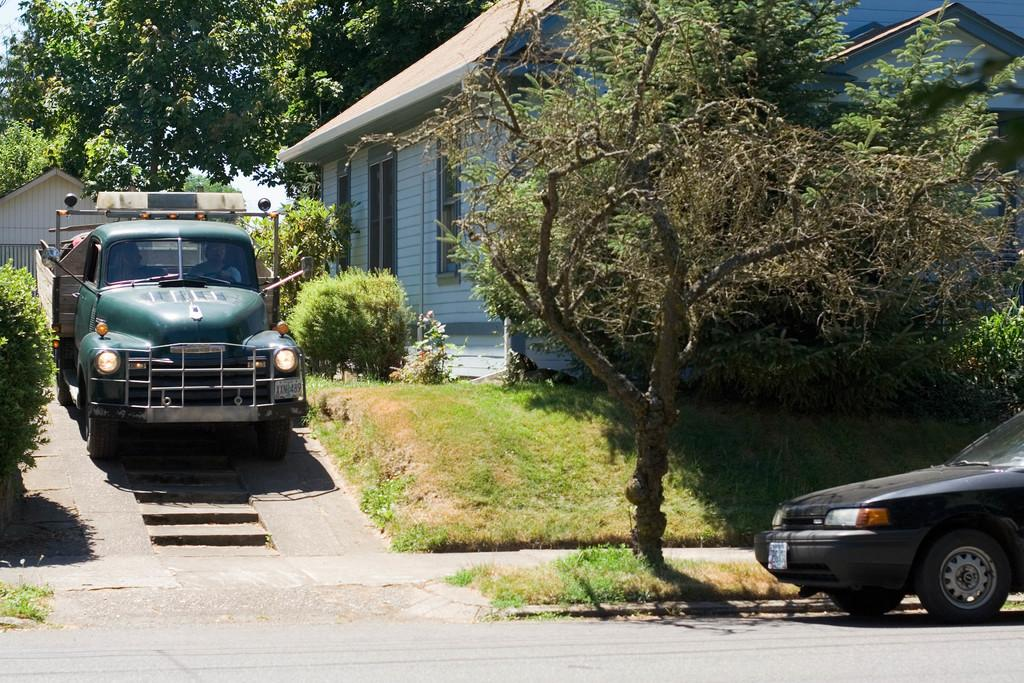What types of objects can be seen in the image in the image? There are vehicles in the image. What can be seen on the ground in the image? The ground is visible in the image. What type of vegetation is present in the image? There is grass, plants, and trees in the image. Are there any architectural features in the image? Yes, there are stairs and houses in the image. What part of the natural environment is visible in the image? The sky is visible in the image. What type of drug is being suggested in the image? There is no suggestion of any drug in the image. Can you tell me how many sons are visible in the image? There are no sons present in the image. 